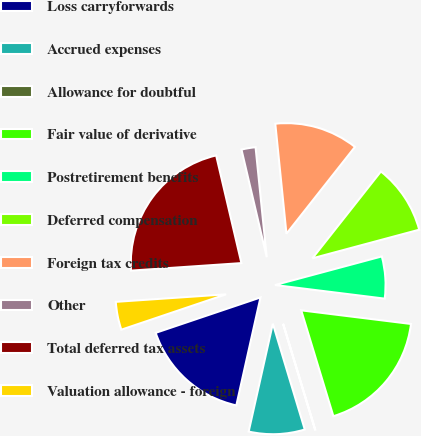Convert chart to OTSL. <chart><loc_0><loc_0><loc_500><loc_500><pie_chart><fcel>Loss carryforwards<fcel>Accrued expenses<fcel>Allowance for doubtful<fcel>Fair value of derivative<fcel>Postretirement benefits<fcel>Deferred compensation<fcel>Foreign tax credits<fcel>Other<fcel>Total deferred tax assets<fcel>Valuation allowance - foreign<nl><fcel>16.31%<fcel>8.17%<fcel>0.03%<fcel>18.34%<fcel>6.13%<fcel>10.2%<fcel>12.24%<fcel>2.06%<fcel>22.41%<fcel>4.1%<nl></chart> 